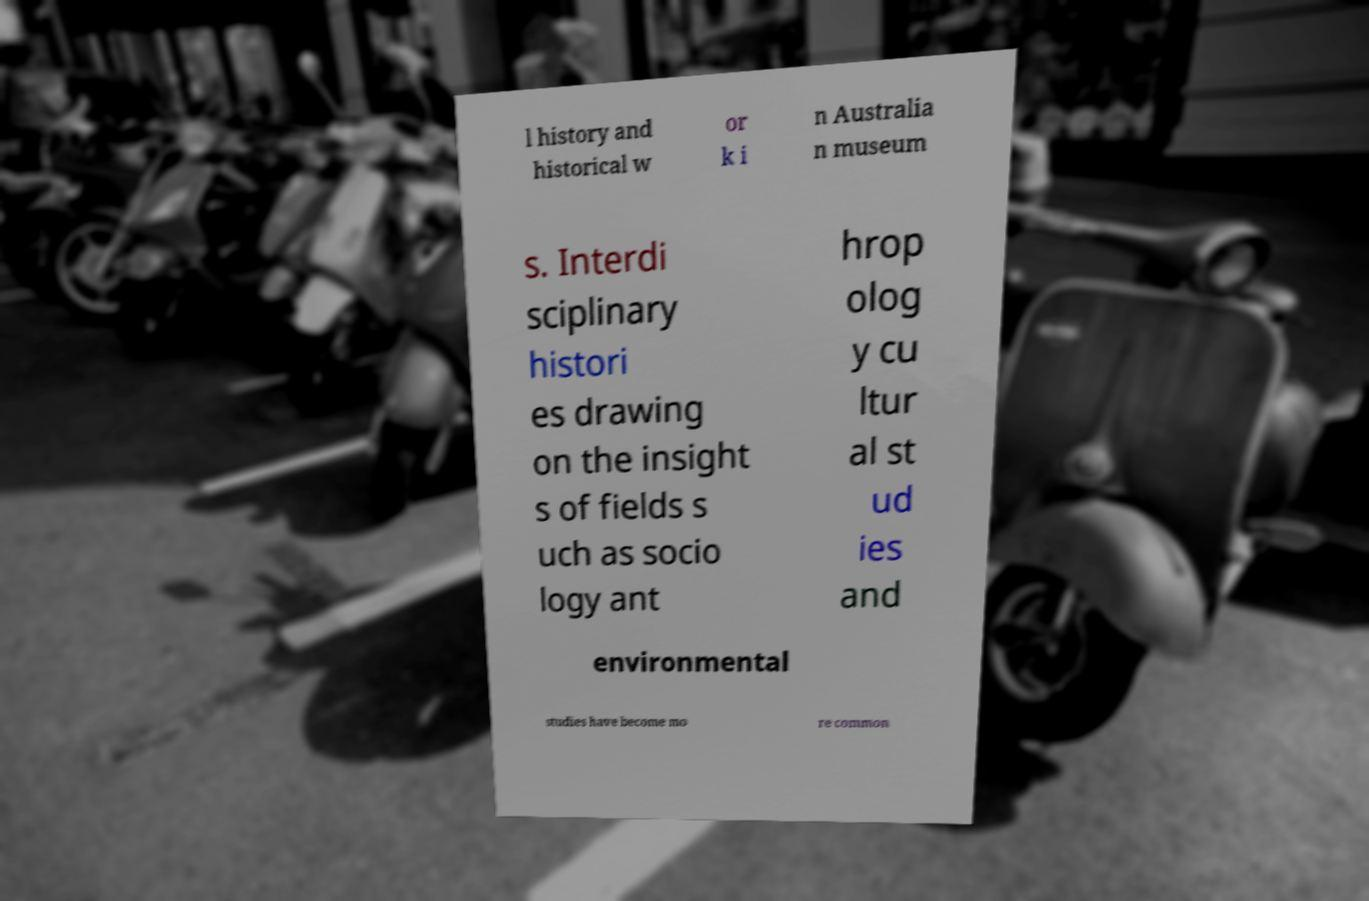For documentation purposes, I need the text within this image transcribed. Could you provide that? l history and historical w or k i n Australia n museum s. Interdi sciplinary histori es drawing on the insight s of fields s uch as socio logy ant hrop olog y cu ltur al st ud ies and environmental studies have become mo re common 